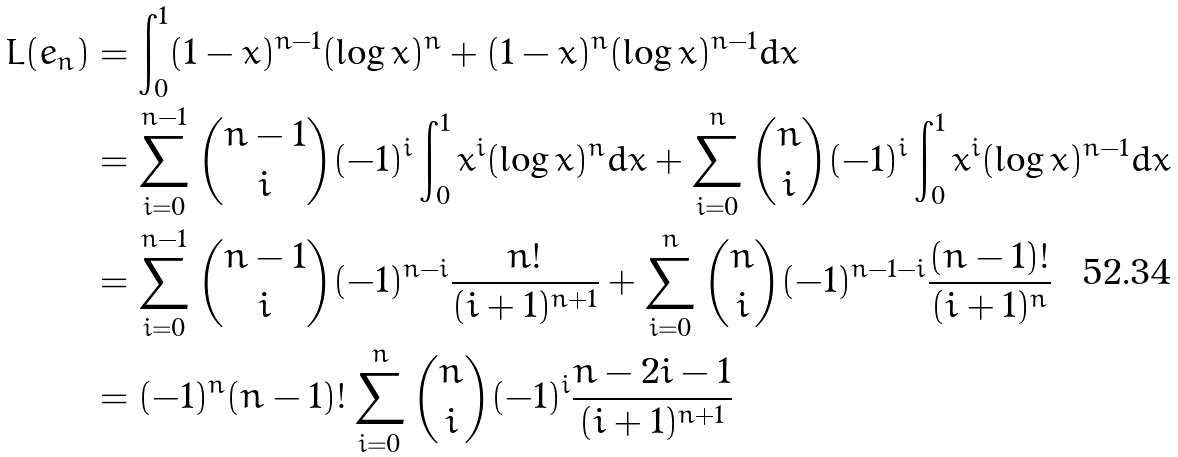Convert formula to latex. <formula><loc_0><loc_0><loc_500><loc_500>L ( e _ { n } ) & = \int _ { 0 } ^ { 1 } ( 1 - x ) ^ { n - 1 } ( \log x ) ^ { n } + ( 1 - x ) ^ { n } ( \log x ) ^ { n - 1 } d x \\ & = \sum _ { i = 0 } ^ { n - 1 } \binom { n - 1 } { i } ( - 1 ) ^ { i } \int _ { 0 } ^ { 1 } x ^ { i } ( \log x ) ^ { n } d x + \sum _ { i = 0 } ^ { n } \binom { n } { i } ( - 1 ) ^ { i } \int _ { 0 } ^ { 1 } x ^ { i } ( \log x ) ^ { n - 1 } d x \\ & = \sum _ { i = 0 } ^ { n - 1 } \binom { n - 1 } { i } ( - 1 ) ^ { n - i } \frac { n ! } { ( i + 1 ) ^ { n + 1 } } + \sum _ { i = 0 } ^ { n } \binom { n } { i } ( - 1 ) ^ { n - 1 - i } \frac { ( n - 1 ) ! } { ( i + 1 ) ^ { n } } \\ & = ( - 1 ) ^ { n } ( n - 1 ) ! \sum _ { i = 0 } ^ { n } \binom { n } { i } ( - 1 ) ^ { i } \frac { n - 2 i - 1 } { ( i + 1 ) ^ { n + 1 } }</formula> 